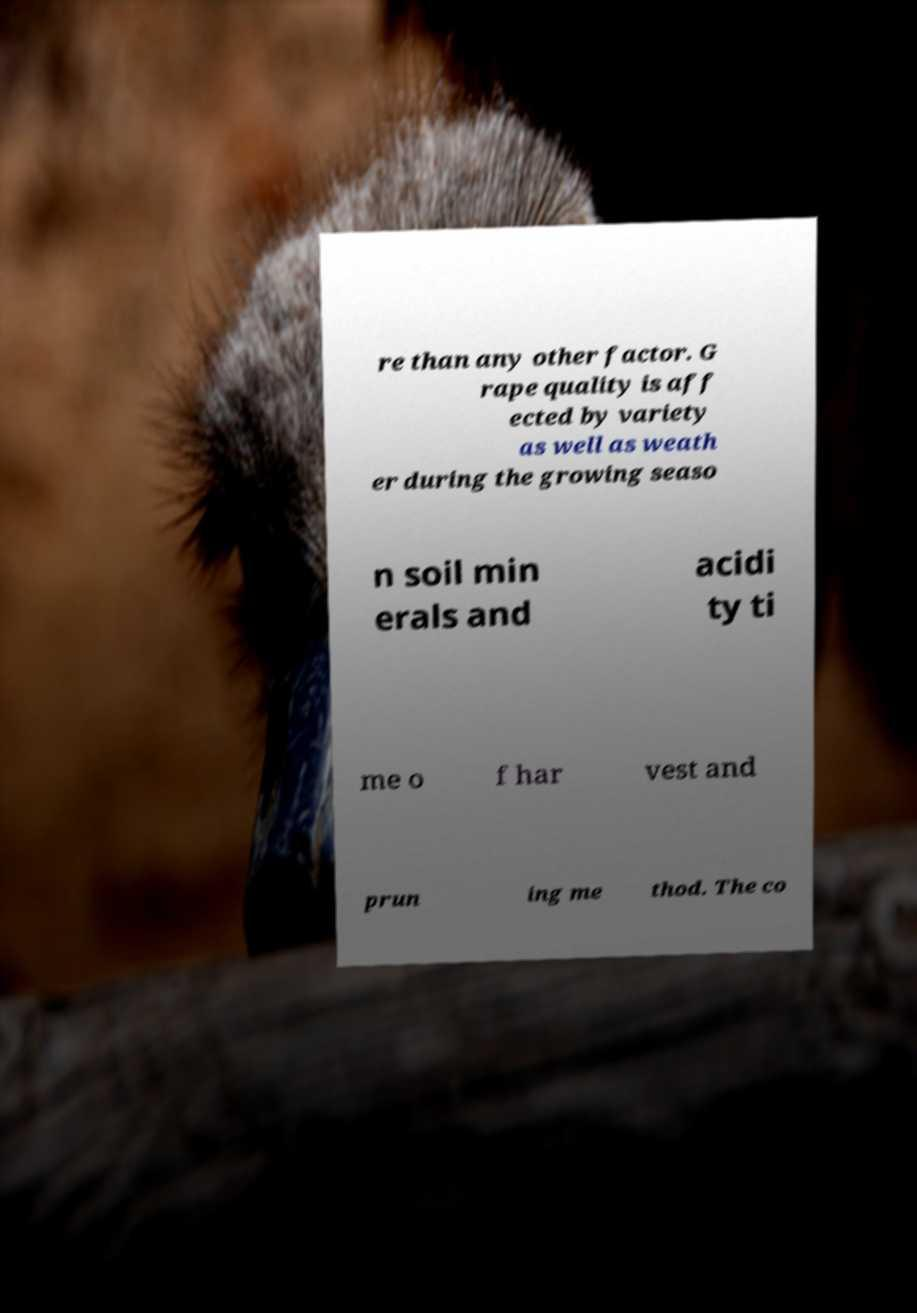There's text embedded in this image that I need extracted. Can you transcribe it verbatim? re than any other factor. G rape quality is aff ected by variety as well as weath er during the growing seaso n soil min erals and acidi ty ti me o f har vest and prun ing me thod. The co 